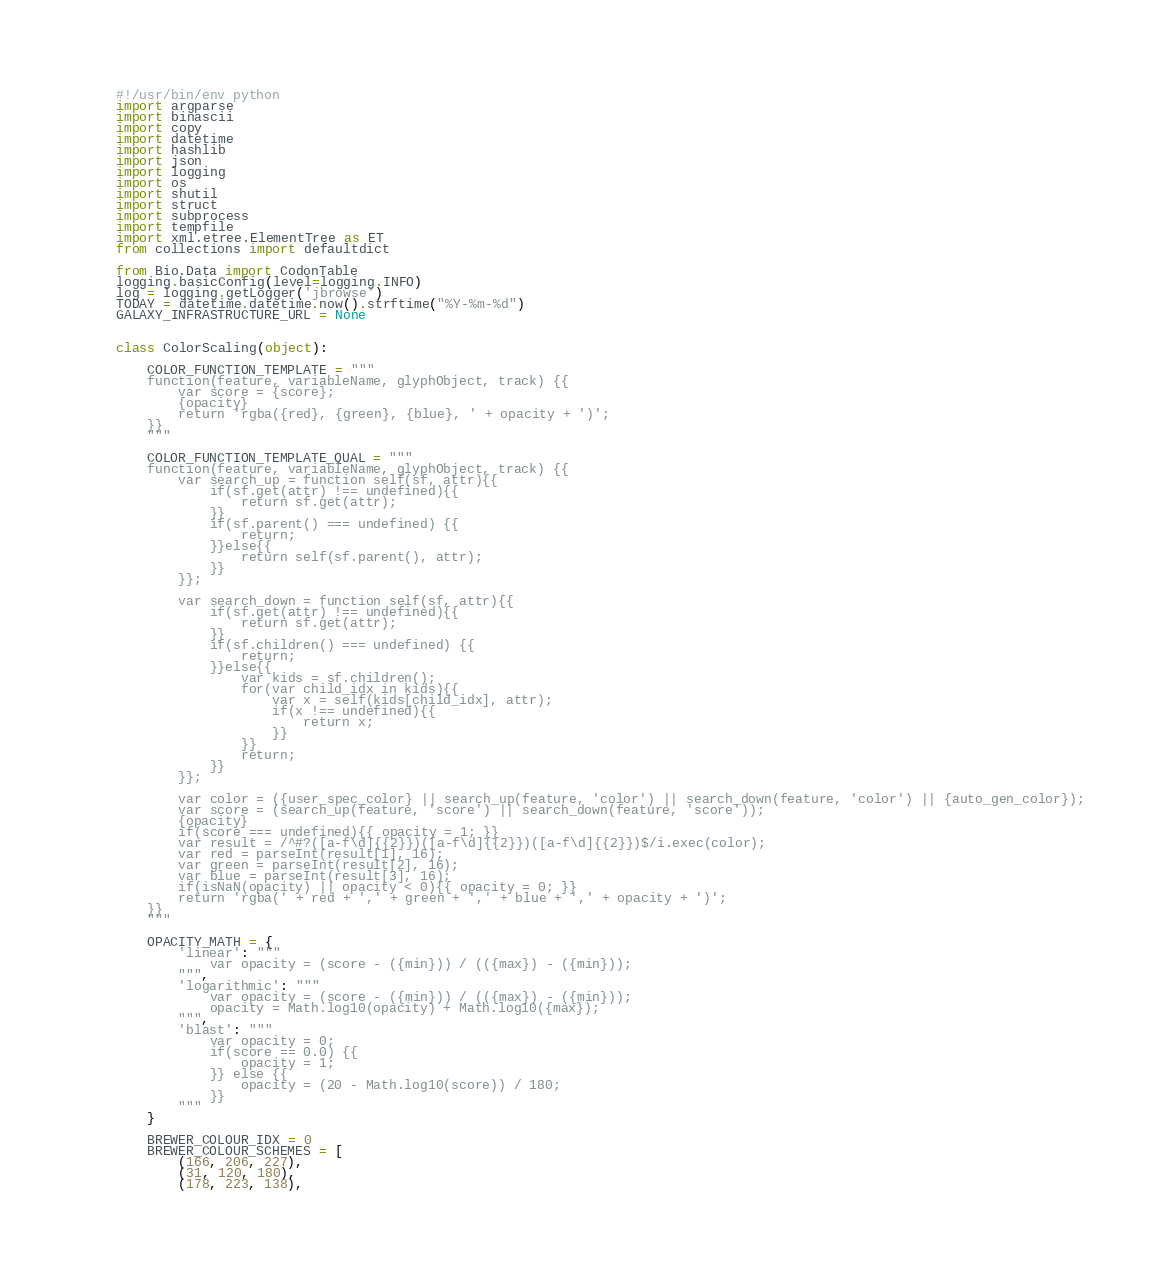<code> <loc_0><loc_0><loc_500><loc_500><_Python_>#!/usr/bin/env python
import argparse
import binascii
import copy
import datetime
import hashlib
import json
import logging
import os
import shutil
import struct
import subprocess
import tempfile
import xml.etree.ElementTree as ET
from collections import defaultdict

from Bio.Data import CodonTable
logging.basicConfig(level=logging.INFO)
log = logging.getLogger('jbrowse')
TODAY = datetime.datetime.now().strftime("%Y-%m-%d")
GALAXY_INFRASTRUCTURE_URL = None


class ColorScaling(object):

    COLOR_FUNCTION_TEMPLATE = """
    function(feature, variableName, glyphObject, track) {{
        var score = {score};
        {opacity}
        return 'rgba({red}, {green}, {blue}, ' + opacity + ')';
    }}
    """

    COLOR_FUNCTION_TEMPLATE_QUAL = """
    function(feature, variableName, glyphObject, track) {{
        var search_up = function self(sf, attr){{
            if(sf.get(attr) !== undefined){{
                return sf.get(attr);
            }}
            if(sf.parent() === undefined) {{
                return;
            }}else{{
                return self(sf.parent(), attr);
            }}
        }};

        var search_down = function self(sf, attr){{
            if(sf.get(attr) !== undefined){{
                return sf.get(attr);
            }}
            if(sf.children() === undefined) {{
                return;
            }}else{{
                var kids = sf.children();
                for(var child_idx in kids){{
                    var x = self(kids[child_idx], attr);
                    if(x !== undefined){{
                        return x;
                    }}
                }}
                return;
            }}
        }};

        var color = ({user_spec_color} || search_up(feature, 'color') || search_down(feature, 'color') || {auto_gen_color});
        var score = (search_up(feature, 'score') || search_down(feature, 'score'));
        {opacity}
        if(score === undefined){{ opacity = 1; }}
        var result = /^#?([a-f\d]{{2}})([a-f\d]{{2}})([a-f\d]{{2}})$/i.exec(color);
        var red = parseInt(result[1], 16);
        var green = parseInt(result[2], 16);
        var blue = parseInt(result[3], 16);
        if(isNaN(opacity) || opacity < 0){{ opacity = 0; }}
        return 'rgba(' + red + ',' + green + ',' + blue + ',' + opacity + ')';
    }}
    """

    OPACITY_MATH = {
        'linear': """
            var opacity = (score - ({min})) / (({max}) - ({min}));
        """,
        'logarithmic': """
            var opacity = (score - ({min})) / (({max}) - ({min}));
            opacity = Math.log10(opacity) + Math.log10({max});
        """,
        'blast': """
            var opacity = 0;
            if(score == 0.0) {{
                opacity = 1;
            }} else {{
                opacity = (20 - Math.log10(score)) / 180;
            }}
        """
    }

    BREWER_COLOUR_IDX = 0
    BREWER_COLOUR_SCHEMES = [
        (166, 206, 227),
        (31, 120, 180),
        (178, 223, 138),</code> 